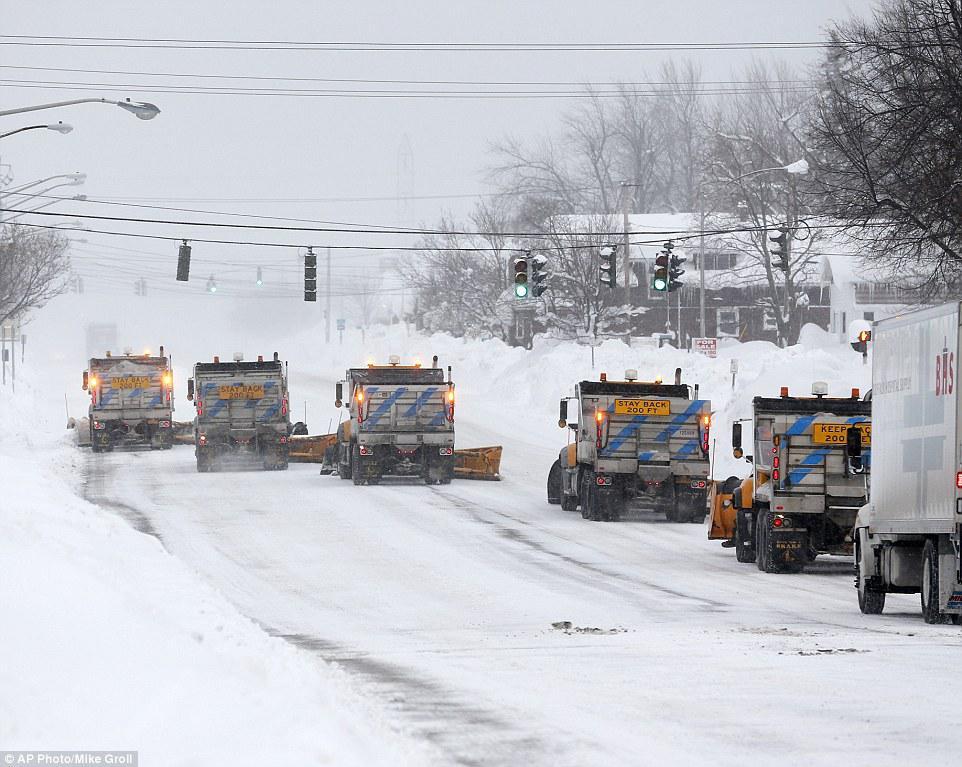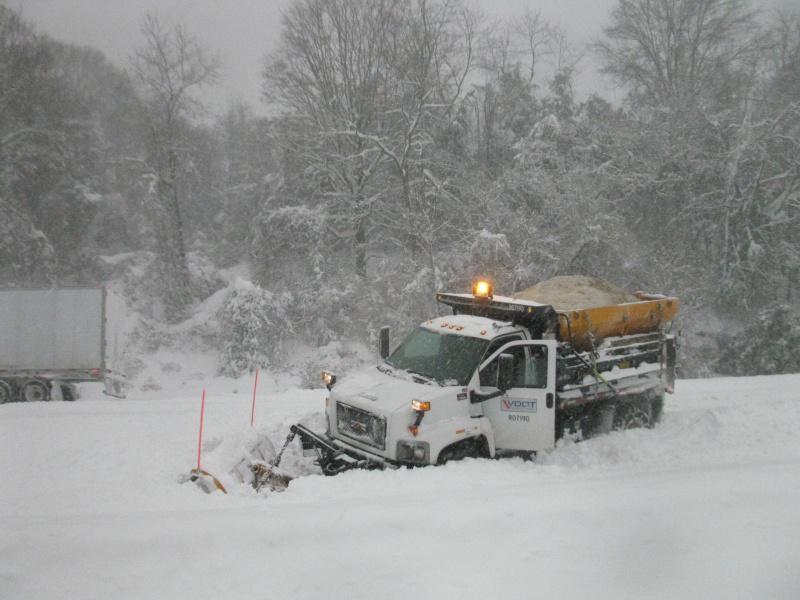The first image is the image on the left, the second image is the image on the right. Analyze the images presented: Is the assertion "It is actively snowing in at least one of the images." valid? Answer yes or no. Yes. 